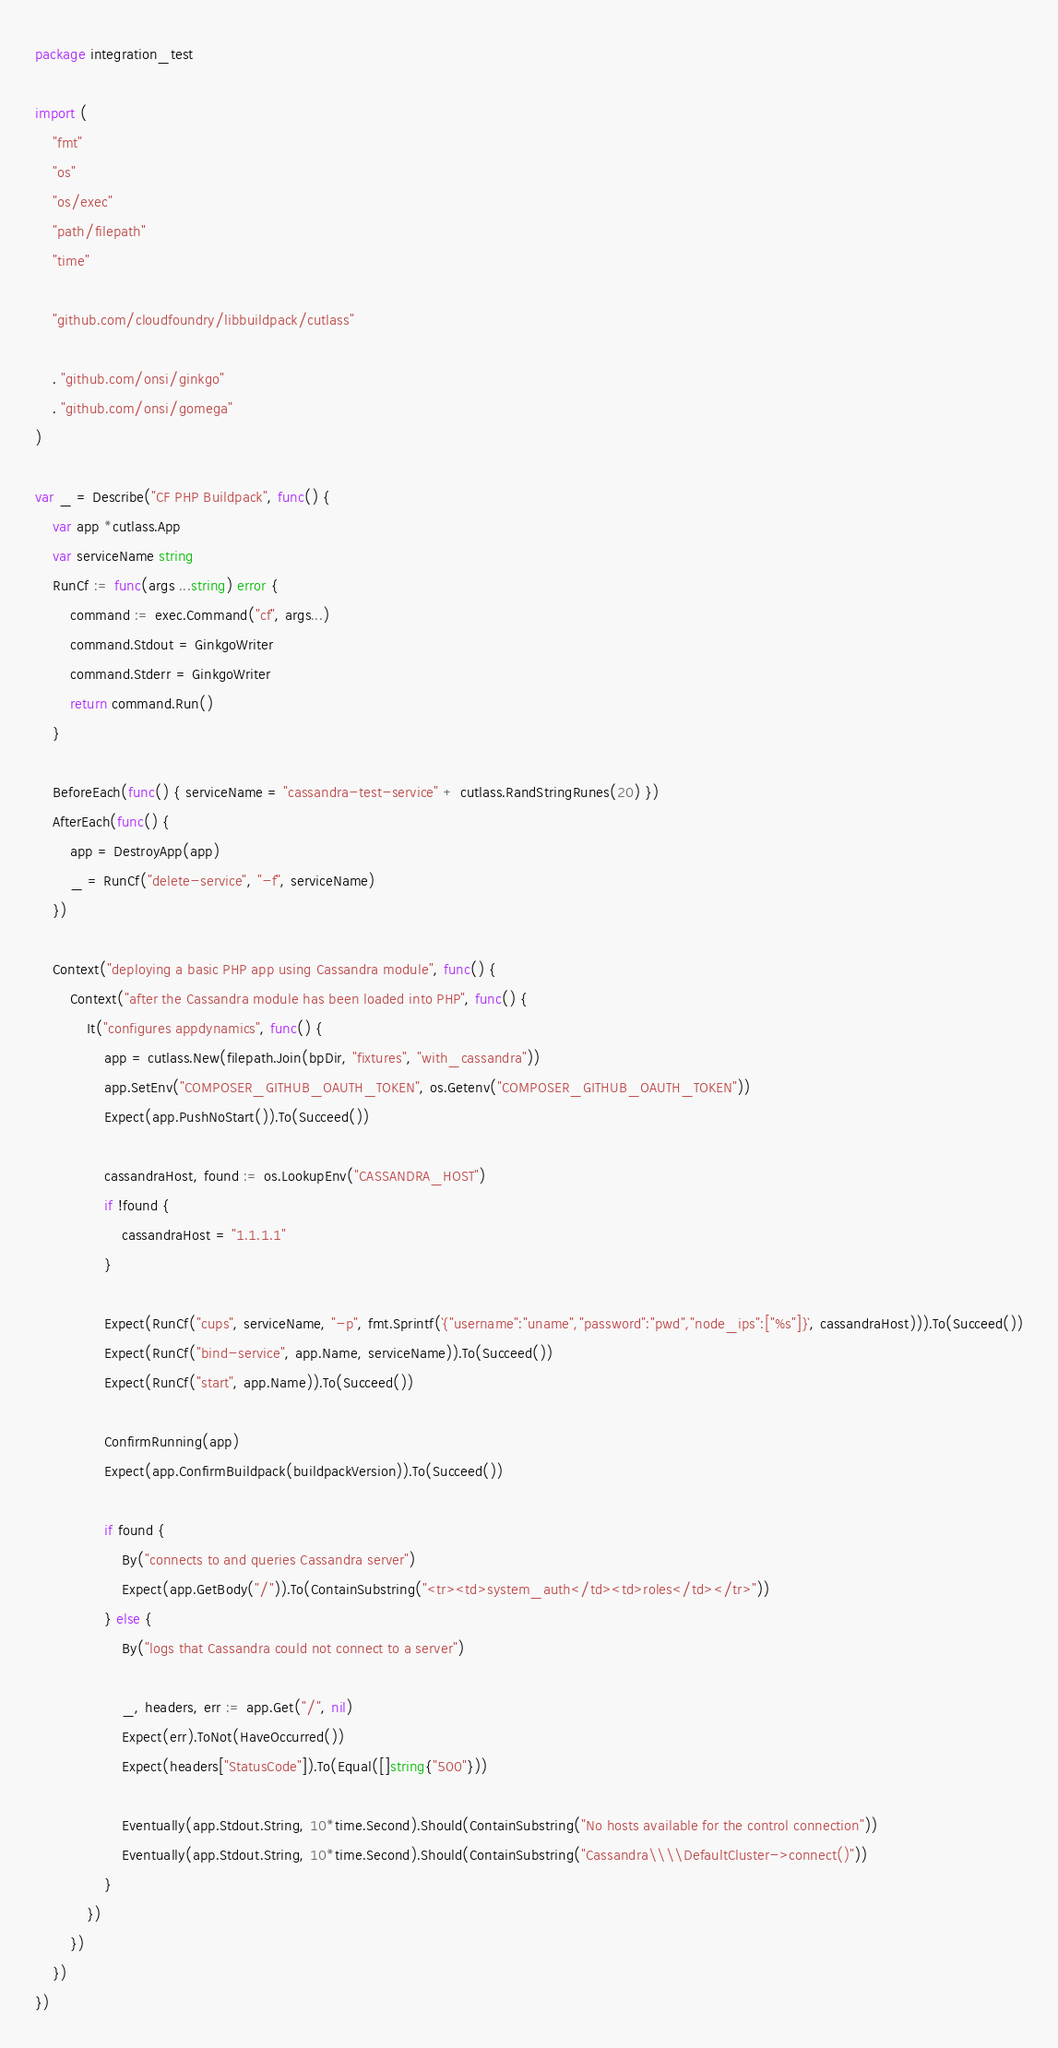Convert code to text. <code><loc_0><loc_0><loc_500><loc_500><_Go_>package integration_test

import (
	"fmt"
	"os"
	"os/exec"
	"path/filepath"
	"time"

	"github.com/cloudfoundry/libbuildpack/cutlass"

	. "github.com/onsi/ginkgo"
	. "github.com/onsi/gomega"
)

var _ = Describe("CF PHP Buildpack", func() {
	var app *cutlass.App
	var serviceName string
	RunCf := func(args ...string) error {
		command := exec.Command("cf", args...)
		command.Stdout = GinkgoWriter
		command.Stderr = GinkgoWriter
		return command.Run()
	}

	BeforeEach(func() { serviceName = "cassandra-test-service" + cutlass.RandStringRunes(20) })
	AfterEach(func() {
		app = DestroyApp(app)
		_ = RunCf("delete-service", "-f", serviceName)
	})

	Context("deploying a basic PHP app using Cassandra module", func() {
		Context("after the Cassandra module has been loaded into PHP", func() {
			It("configures appdynamics", func() {
				app = cutlass.New(filepath.Join(bpDir, "fixtures", "with_cassandra"))
				app.SetEnv("COMPOSER_GITHUB_OAUTH_TOKEN", os.Getenv("COMPOSER_GITHUB_OAUTH_TOKEN"))
				Expect(app.PushNoStart()).To(Succeed())

				cassandraHost, found := os.LookupEnv("CASSANDRA_HOST")
				if !found {
					cassandraHost = "1.1.1.1"
				}

				Expect(RunCf("cups", serviceName, "-p", fmt.Sprintf(`{"username":"uname","password":"pwd","node_ips":["%s"]}`, cassandraHost))).To(Succeed())
				Expect(RunCf("bind-service", app.Name, serviceName)).To(Succeed())
				Expect(RunCf("start", app.Name)).To(Succeed())

				ConfirmRunning(app)
				Expect(app.ConfirmBuildpack(buildpackVersion)).To(Succeed())

				if found {
					By("connects to and queries Cassandra server")
					Expect(app.GetBody("/")).To(ContainSubstring("<tr><td>system_auth</td><td>roles</td></tr>"))
				} else {
					By("logs that Cassandra could not connect to a server")

					_, headers, err := app.Get("/", nil)
					Expect(err).ToNot(HaveOccurred())
					Expect(headers["StatusCode"]).To(Equal([]string{"500"}))

					Eventually(app.Stdout.String, 10*time.Second).Should(ContainSubstring("No hosts available for the control connection"))
					Eventually(app.Stdout.String, 10*time.Second).Should(ContainSubstring("Cassandra\\\\DefaultCluster->connect()"))
				}
			})
		})
	})
})
</code> 